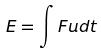<formula> <loc_0><loc_0><loc_500><loc_500>E = \int F u d t</formula> 